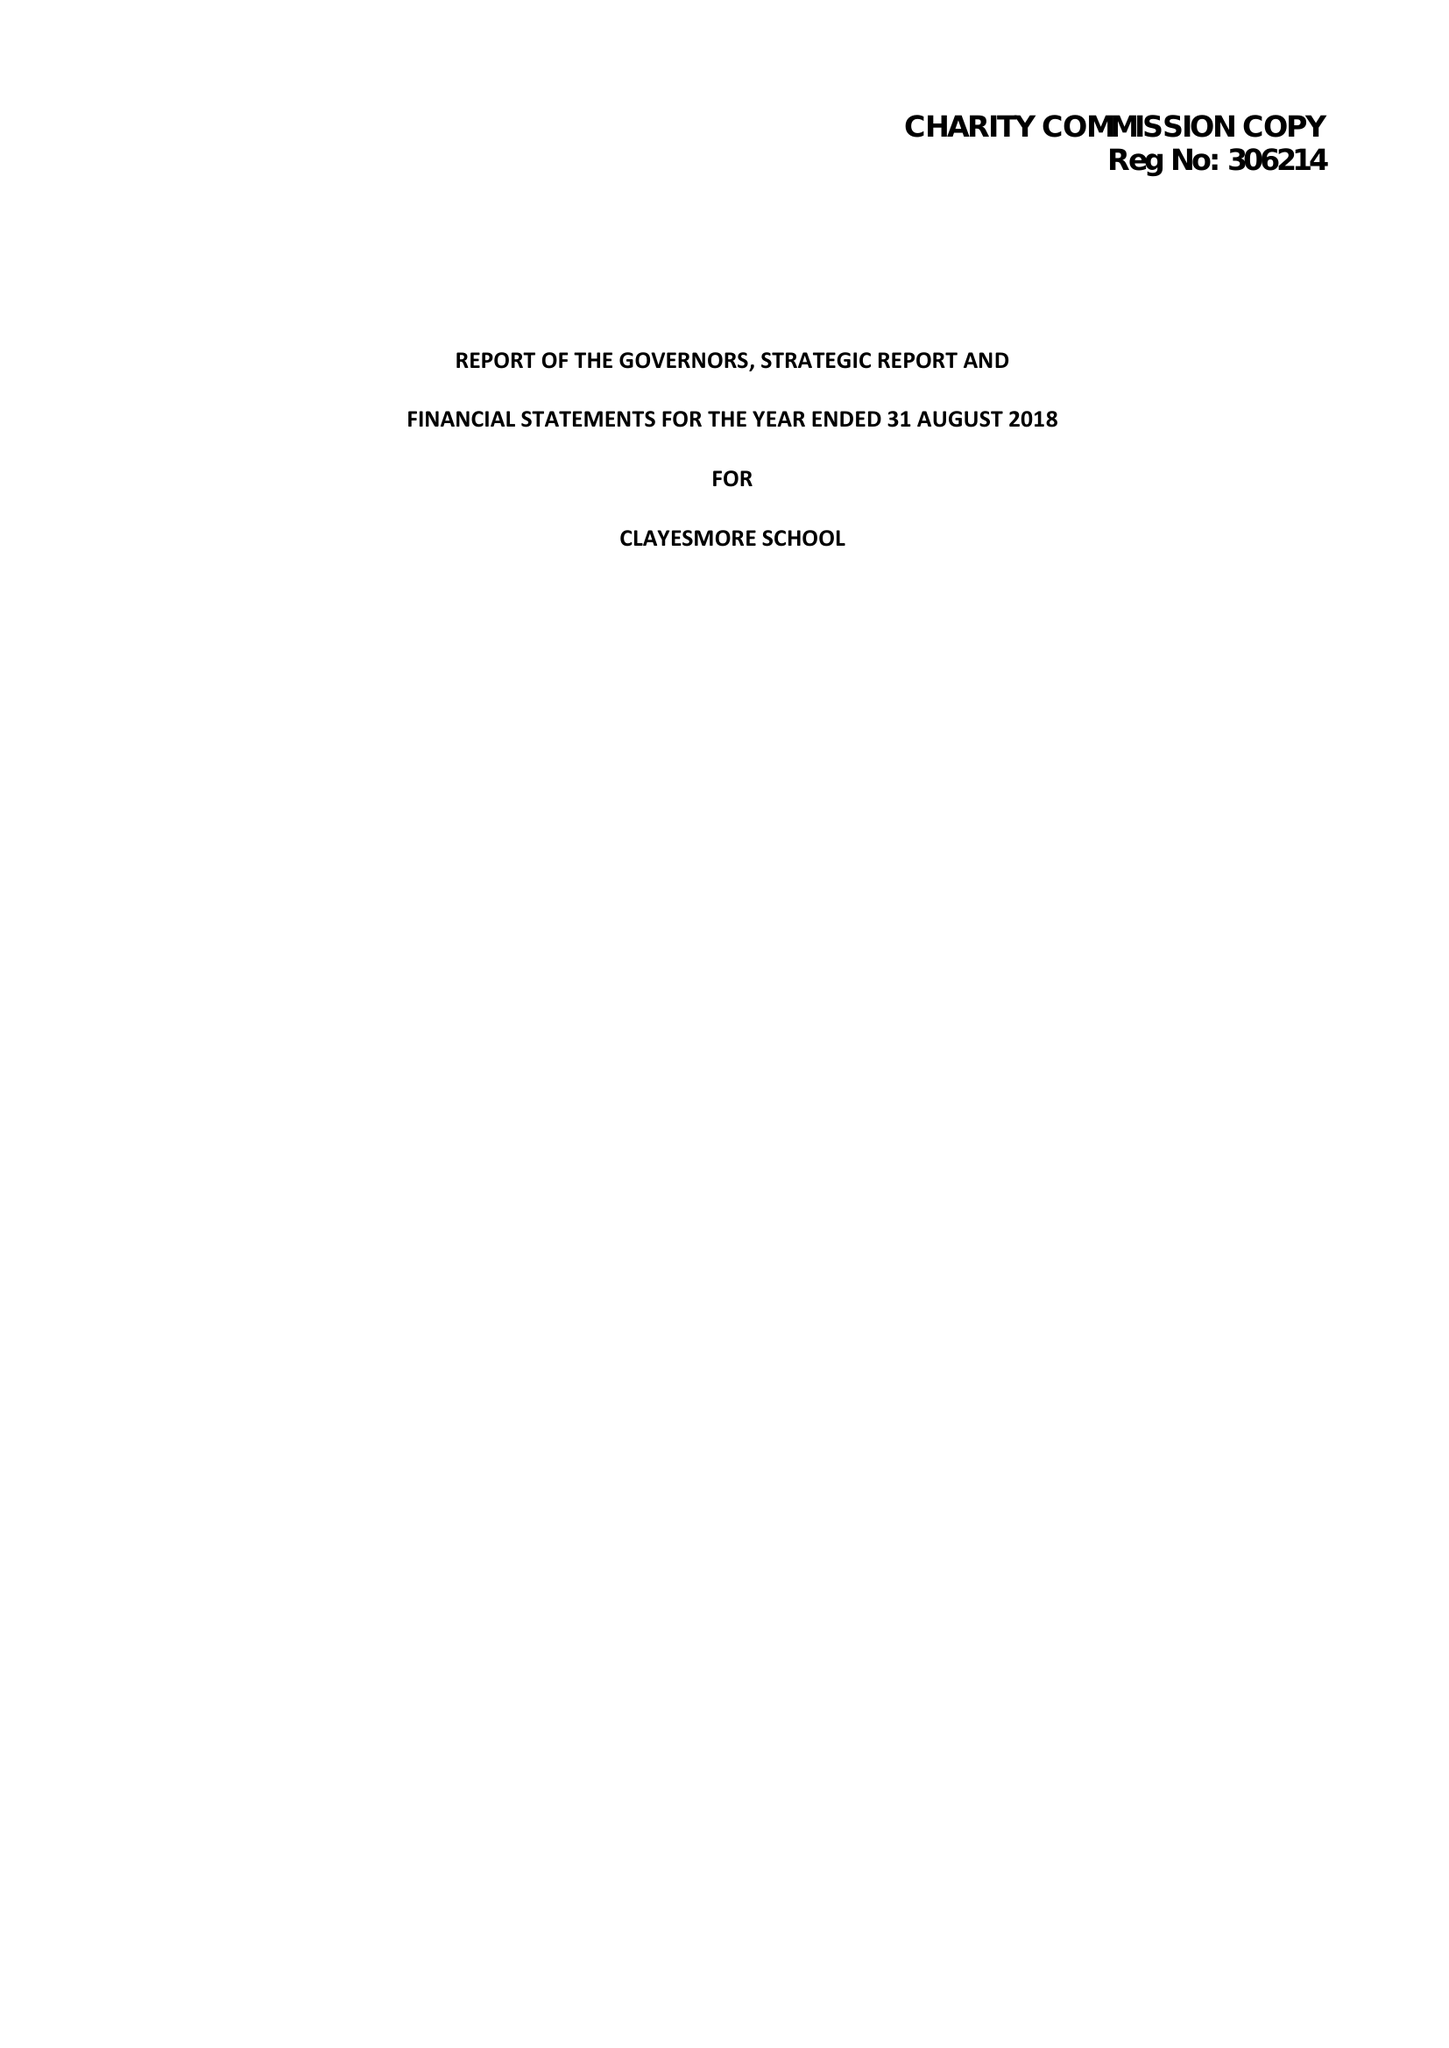What is the value for the charity_name?
Answer the question using a single word or phrase. Clayesmore School 